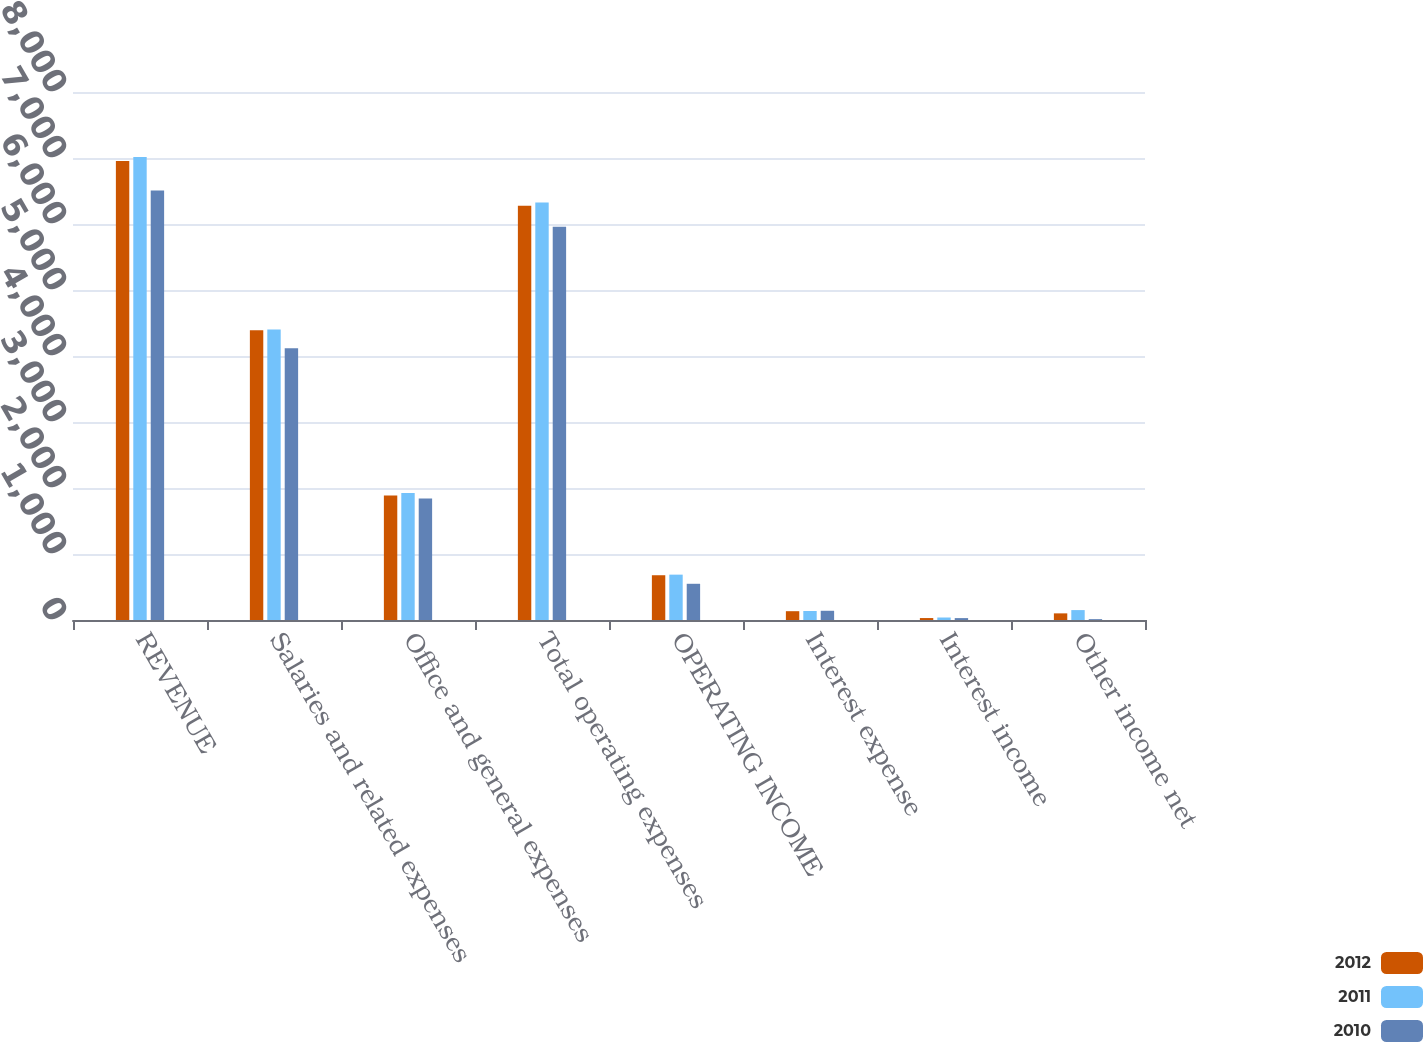Convert chart. <chart><loc_0><loc_0><loc_500><loc_500><stacked_bar_chart><ecel><fcel>REVENUE<fcel>Salaries and related expenses<fcel>Office and general expenses<fcel>Total operating expenses<fcel>OPERATING INCOME<fcel>Interest expense<fcel>Interest income<fcel>Other income net<nl><fcel>2012<fcel>6956.2<fcel>4391.9<fcel>1886<fcel>6277.9<fcel>678.3<fcel>133.5<fcel>29.5<fcel>100.5<nl><fcel>2011<fcel>7014.6<fcel>4402.1<fcel>1925.3<fcel>6327.4<fcel>687.2<fcel>136.8<fcel>37.8<fcel>150.2<nl><fcel>2010<fcel>6507.3<fcel>4117<fcel>1841.6<fcel>5958.6<fcel>548.7<fcel>139.7<fcel>28.7<fcel>12.9<nl></chart> 